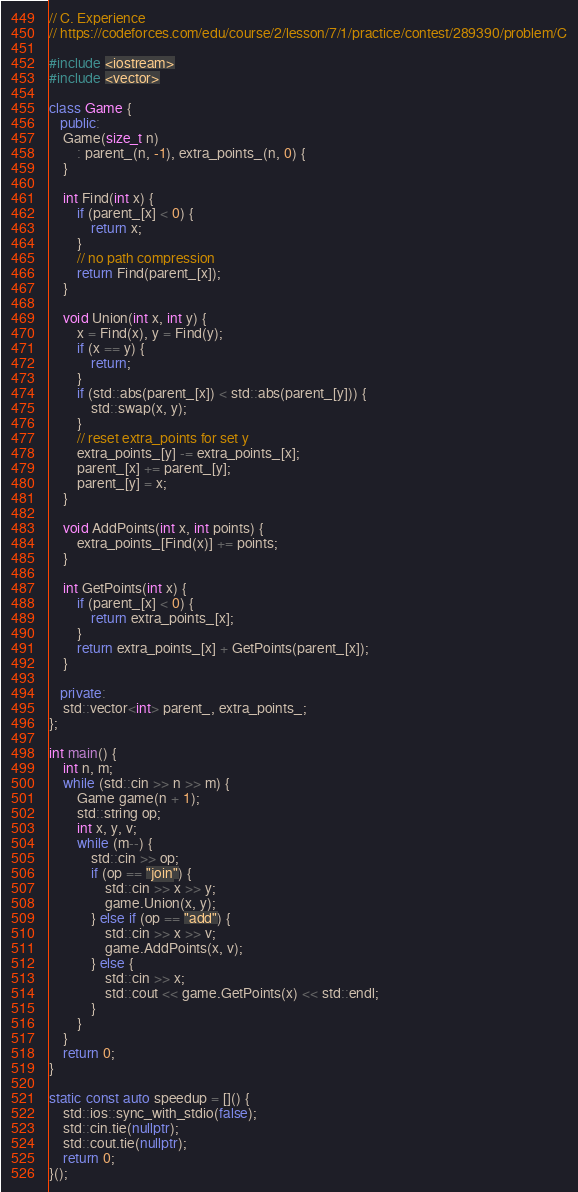Convert code to text. <code><loc_0><loc_0><loc_500><loc_500><_C++_>// C. Experience
// https://codeforces.com/edu/course/2/lesson/7/1/practice/contest/289390/problem/C

#include <iostream>
#include <vector>

class Game {
   public:
    Game(size_t n)
        : parent_(n, -1), extra_points_(n, 0) {
    }

    int Find(int x) {
        if (parent_[x] < 0) {
            return x;
        }
        // no path compression
        return Find(parent_[x]);
    }

    void Union(int x, int y) {
        x = Find(x), y = Find(y);
        if (x == y) {
            return;
        }
        if (std::abs(parent_[x]) < std::abs(parent_[y])) {
            std::swap(x, y);
        }
        // reset extra_points for set y
        extra_points_[y] -= extra_points_[x];
        parent_[x] += parent_[y];
        parent_[y] = x;
    }

    void AddPoints(int x, int points) {
        extra_points_[Find(x)] += points;
    }

    int GetPoints(int x) {
        if (parent_[x] < 0) {
            return extra_points_[x];
        }
        return extra_points_[x] + GetPoints(parent_[x]);
    }

   private:
    std::vector<int> parent_, extra_points_;
};

int main() {
    int n, m;
    while (std::cin >> n >> m) {
        Game game(n + 1);
        std::string op;
        int x, y, v;
        while (m--) {
            std::cin >> op;
            if (op == "join") {
                std::cin >> x >> y;
                game.Union(x, y);
            } else if (op == "add") {
                std::cin >> x >> v;
                game.AddPoints(x, v);
            } else {
                std::cin >> x;
                std::cout << game.GetPoints(x) << std::endl;
            }
        }
    }
    return 0;
}

static const auto speedup = []() {
    std::ios::sync_with_stdio(false);
    std::cin.tie(nullptr);
    std::cout.tie(nullptr);
    return 0;
}();
</code> 